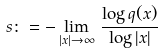<formula> <loc_0><loc_0><loc_500><loc_500>s \colon = - \lim _ { | x | \to \infty } \, \frac { \log q ( x ) } { \log | x | }</formula> 